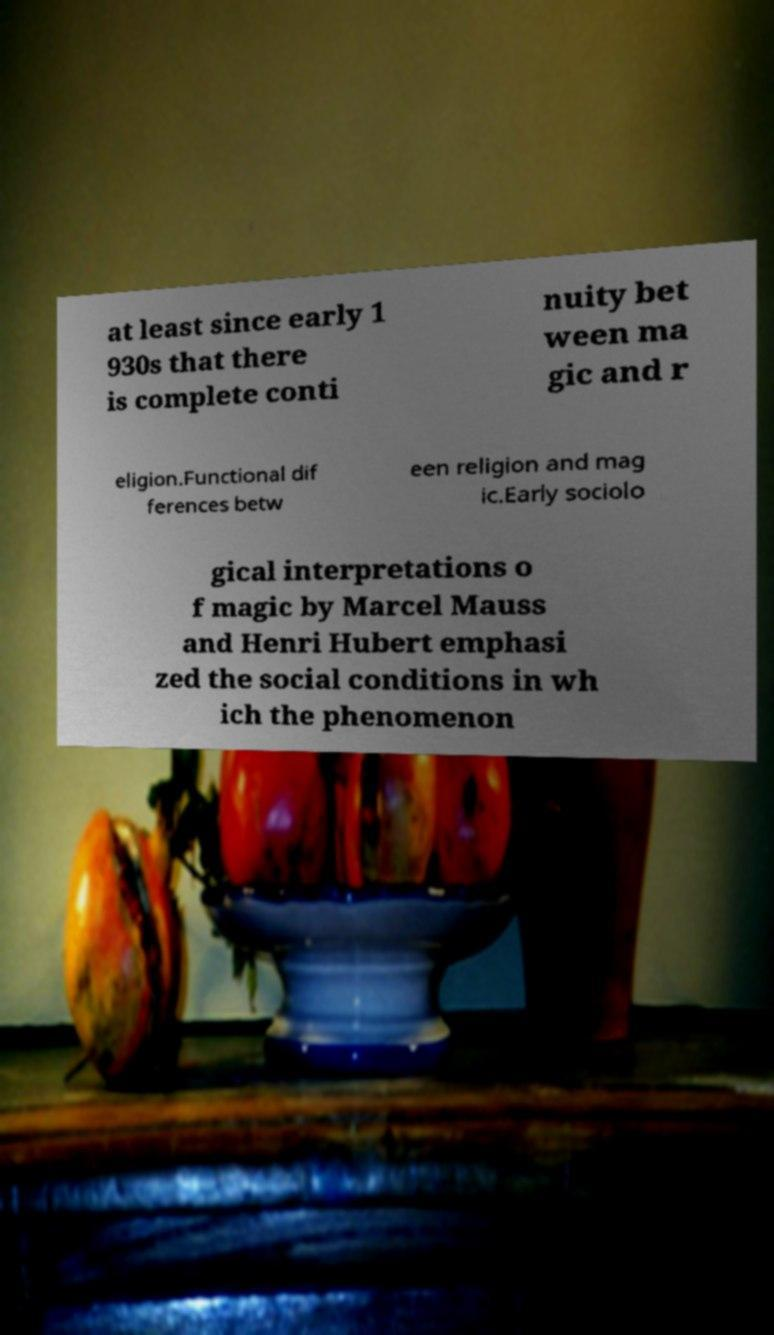Could you extract and type out the text from this image? at least since early 1 930s that there is complete conti nuity bet ween ma gic and r eligion.Functional dif ferences betw een religion and mag ic.Early sociolo gical interpretations o f magic by Marcel Mauss and Henri Hubert emphasi zed the social conditions in wh ich the phenomenon 